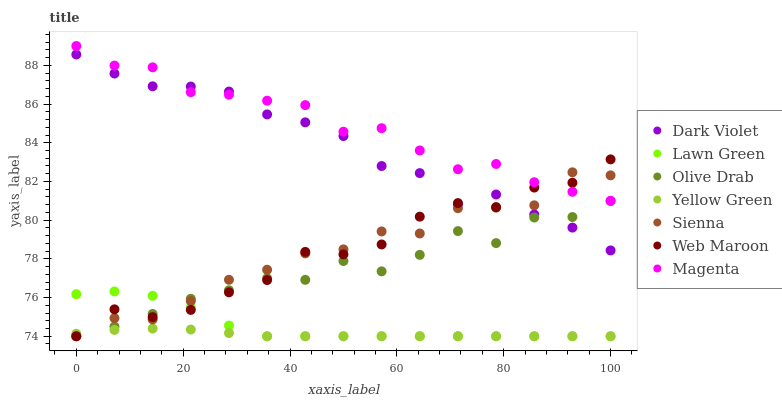Does Yellow Green have the minimum area under the curve?
Answer yes or no. Yes. Does Magenta have the maximum area under the curve?
Answer yes or no. Yes. Does Web Maroon have the minimum area under the curve?
Answer yes or no. No. Does Web Maroon have the maximum area under the curve?
Answer yes or no. No. Is Yellow Green the smoothest?
Answer yes or no. Yes. Is Web Maroon the roughest?
Answer yes or no. Yes. Is Web Maroon the smoothest?
Answer yes or no. No. Is Yellow Green the roughest?
Answer yes or no. No. Does Lawn Green have the lowest value?
Answer yes or no. Yes. Does Dark Violet have the lowest value?
Answer yes or no. No. Does Magenta have the highest value?
Answer yes or no. Yes. Does Web Maroon have the highest value?
Answer yes or no. No. Is Lawn Green less than Dark Violet?
Answer yes or no. Yes. Is Dark Violet greater than Lawn Green?
Answer yes or no. Yes. Does Web Maroon intersect Yellow Green?
Answer yes or no. Yes. Is Web Maroon less than Yellow Green?
Answer yes or no. No. Is Web Maroon greater than Yellow Green?
Answer yes or no. No. Does Lawn Green intersect Dark Violet?
Answer yes or no. No. 